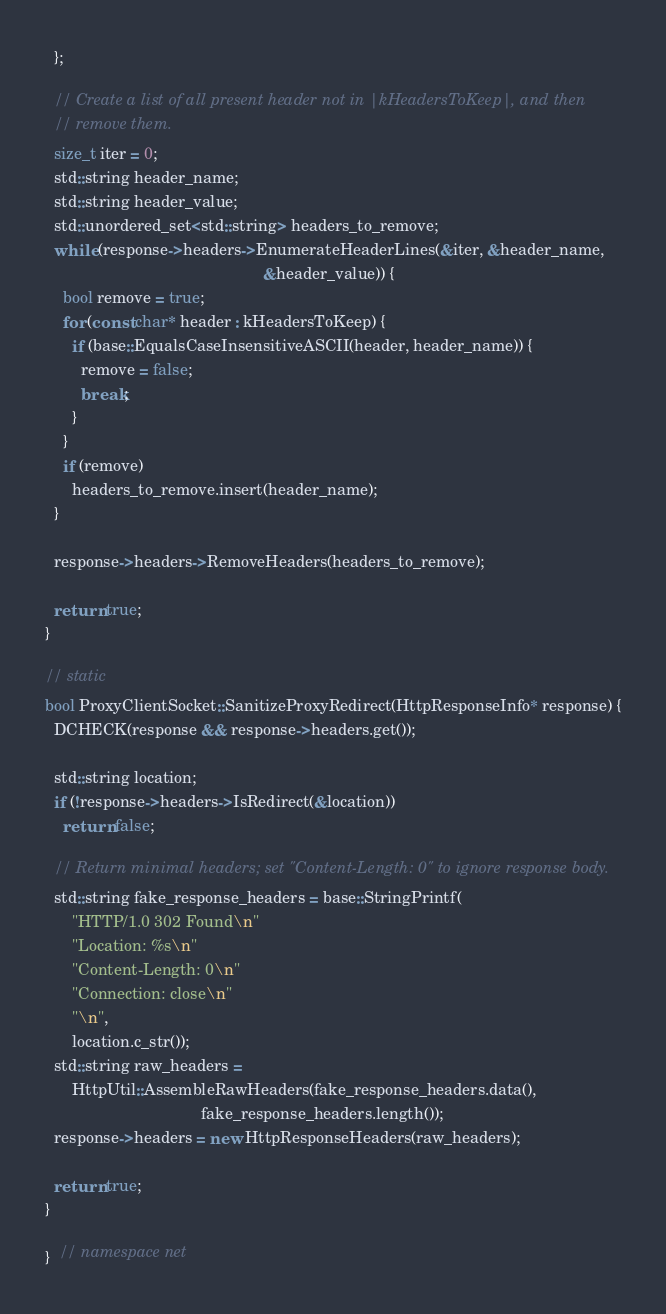Convert code to text. <code><loc_0><loc_0><loc_500><loc_500><_C++_>  };

  // Create a list of all present header not in |kHeadersToKeep|, and then
  // remove them.
  size_t iter = 0;
  std::string header_name;
  std::string header_value;
  std::unordered_set<std::string> headers_to_remove;
  while (response->headers->EnumerateHeaderLines(&iter, &header_name,
                                                 &header_value)) {
    bool remove = true;
    for (const char* header : kHeadersToKeep) {
      if (base::EqualsCaseInsensitiveASCII(header, header_name)) {
        remove = false;
        break;
      }
    }
    if (remove)
      headers_to_remove.insert(header_name);
  }

  response->headers->RemoveHeaders(headers_to_remove);

  return true;
}

// static
bool ProxyClientSocket::SanitizeProxyRedirect(HttpResponseInfo* response) {
  DCHECK(response && response->headers.get());

  std::string location;
  if (!response->headers->IsRedirect(&location))
    return false;

  // Return minimal headers; set "Content-Length: 0" to ignore response body.
  std::string fake_response_headers = base::StringPrintf(
      "HTTP/1.0 302 Found\n"
      "Location: %s\n"
      "Content-Length: 0\n"
      "Connection: close\n"
      "\n",
      location.c_str());
  std::string raw_headers =
      HttpUtil::AssembleRawHeaders(fake_response_headers.data(),
                                   fake_response_headers.length());
  response->headers = new HttpResponseHeaders(raw_headers);

  return true;
}

}  // namespace net
</code> 